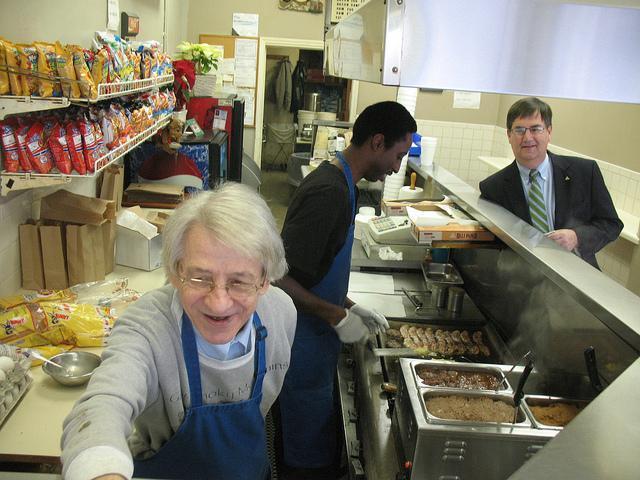How many people can you see?
Give a very brief answer. 3. How many windows are on the train in the picture?
Give a very brief answer. 0. 